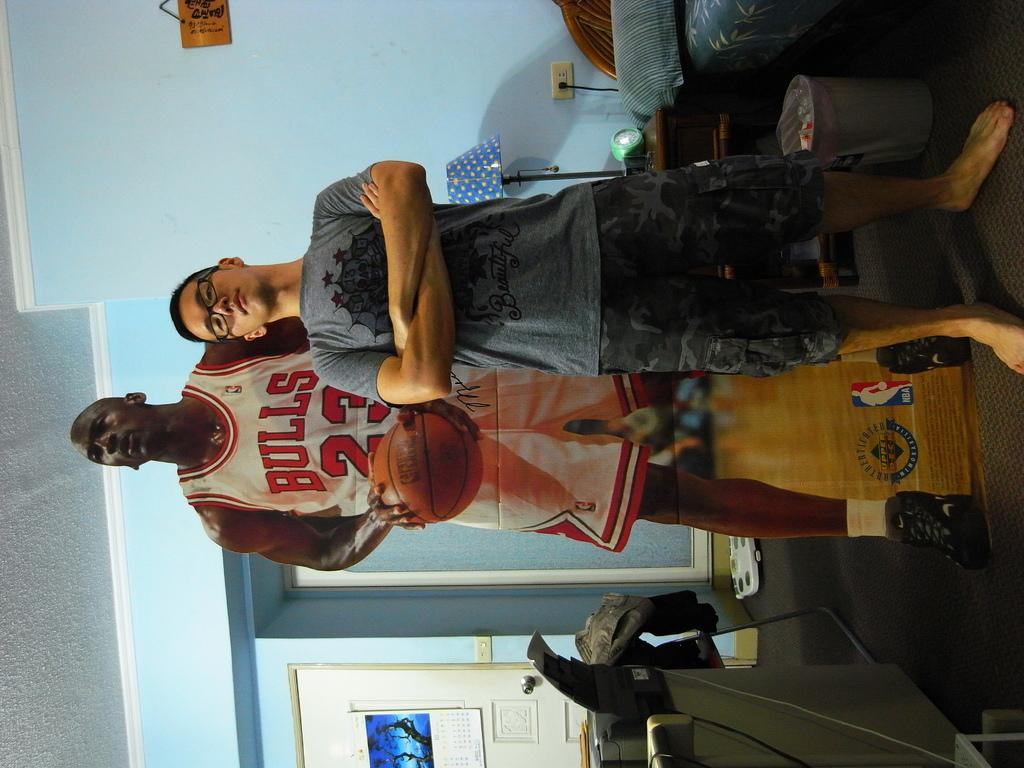<image>
Render a clear and concise summary of the photo. the man wearing Bulls 23 jersey is holding the ball 